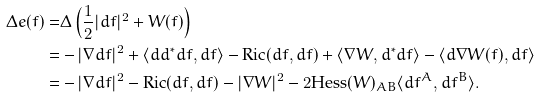Convert formula to latex. <formula><loc_0><loc_0><loc_500><loc_500>\Delta e ( f ) = & \Delta \left ( \frac { 1 } { 2 } | d f | ^ { 2 } + W ( f ) \right ) \\ = & - | \nabla d f | ^ { 2 } + \langle d d ^ { * } d f , d f \rangle - \text {Ric} ( d f , d f ) + \langle \nabla W , d ^ { * } d f \rangle - \langle d \nabla W ( f ) , d f \rangle \\ = & - | \nabla d f | ^ { 2 } - \text {Ric} ( d f , d f ) - | \nabla W | ^ { 2 } - 2 \text {Hess} ( W ) _ { A B } \langle d f ^ { A } , d f ^ { B } \rangle .</formula> 